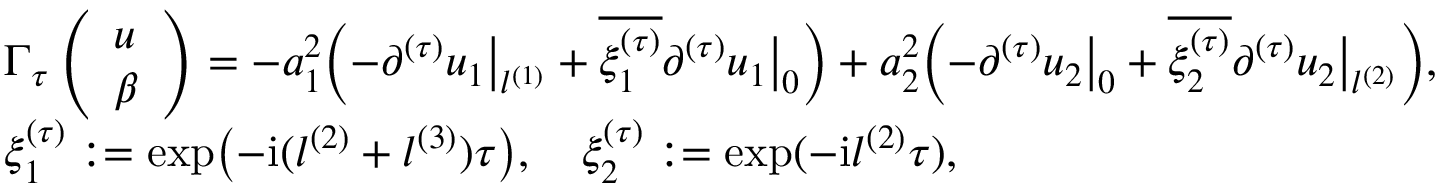<formula> <loc_0><loc_0><loc_500><loc_500>\begin{array} { r l } & { \Gamma _ { \tau } \left ( \begin{array} { l } { u } \\ { \beta } \end{array} \right ) = - a _ { 1 } ^ { 2 } \left ( - \partial ^ { ( \tau ) } u _ { 1 } \left | _ { l ^ { ( 1 ) } } + \overline { { \xi _ { 1 } ^ { ( \tau ) } } } \partial ^ { ( \tau ) } u _ { 1 } \right | _ { 0 } \right ) + a _ { 2 } ^ { 2 } \left ( - \partial ^ { ( \tau ) } u _ { 2 } \left | _ { 0 } + \overline { { \xi _ { 2 } ^ { ( \tau ) } } } \partial ^ { ( \tau ) } u _ { 2 } \right | _ { l ^ { ( 2 ) } } \right ) , } \\ & { \xi _ { 1 } ^ { ( \tau ) } \colon = \exp \left ( - i ( l ^ { ( 2 ) } + l ^ { ( 3 ) } ) \tau \right ) , \quad \xi _ { 2 } ^ { ( \tau ) } \colon = \exp ( - i l ^ { ( 2 ) } \tau ) , } \end{array}</formula> 